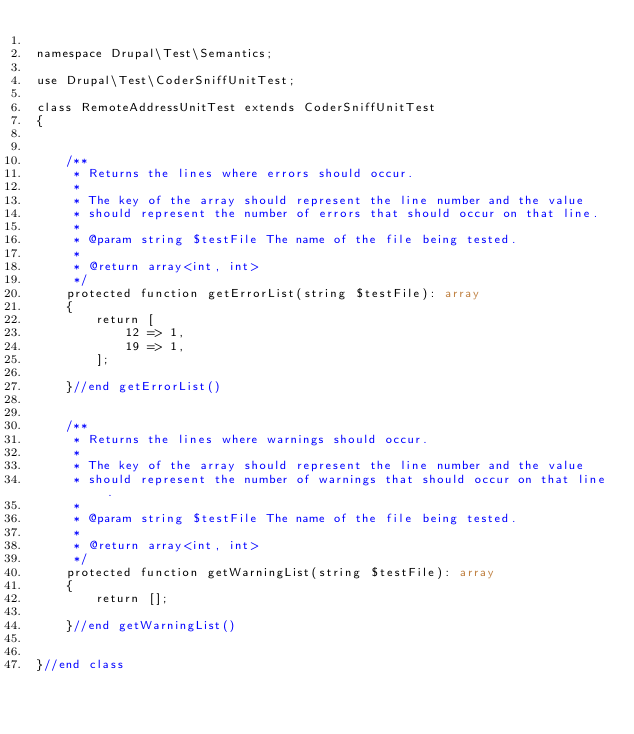<code> <loc_0><loc_0><loc_500><loc_500><_PHP_>
namespace Drupal\Test\Semantics;

use Drupal\Test\CoderSniffUnitTest;

class RemoteAddressUnitTest extends CoderSniffUnitTest
{


    /**
     * Returns the lines where errors should occur.
     *
     * The key of the array should represent the line number and the value
     * should represent the number of errors that should occur on that line.
     *
     * @param string $testFile The name of the file being tested.
     *
     * @return array<int, int>
     */
    protected function getErrorList(string $testFile): array
    {
        return [
            12 => 1,
            19 => 1,
        ];

    }//end getErrorList()


    /**
     * Returns the lines where warnings should occur.
     *
     * The key of the array should represent the line number and the value
     * should represent the number of warnings that should occur on that line.
     *
     * @param string $testFile The name of the file being tested.
     *
     * @return array<int, int>
     */
    protected function getWarningList(string $testFile): array
    {
        return [];

    }//end getWarningList()


}//end class
</code> 